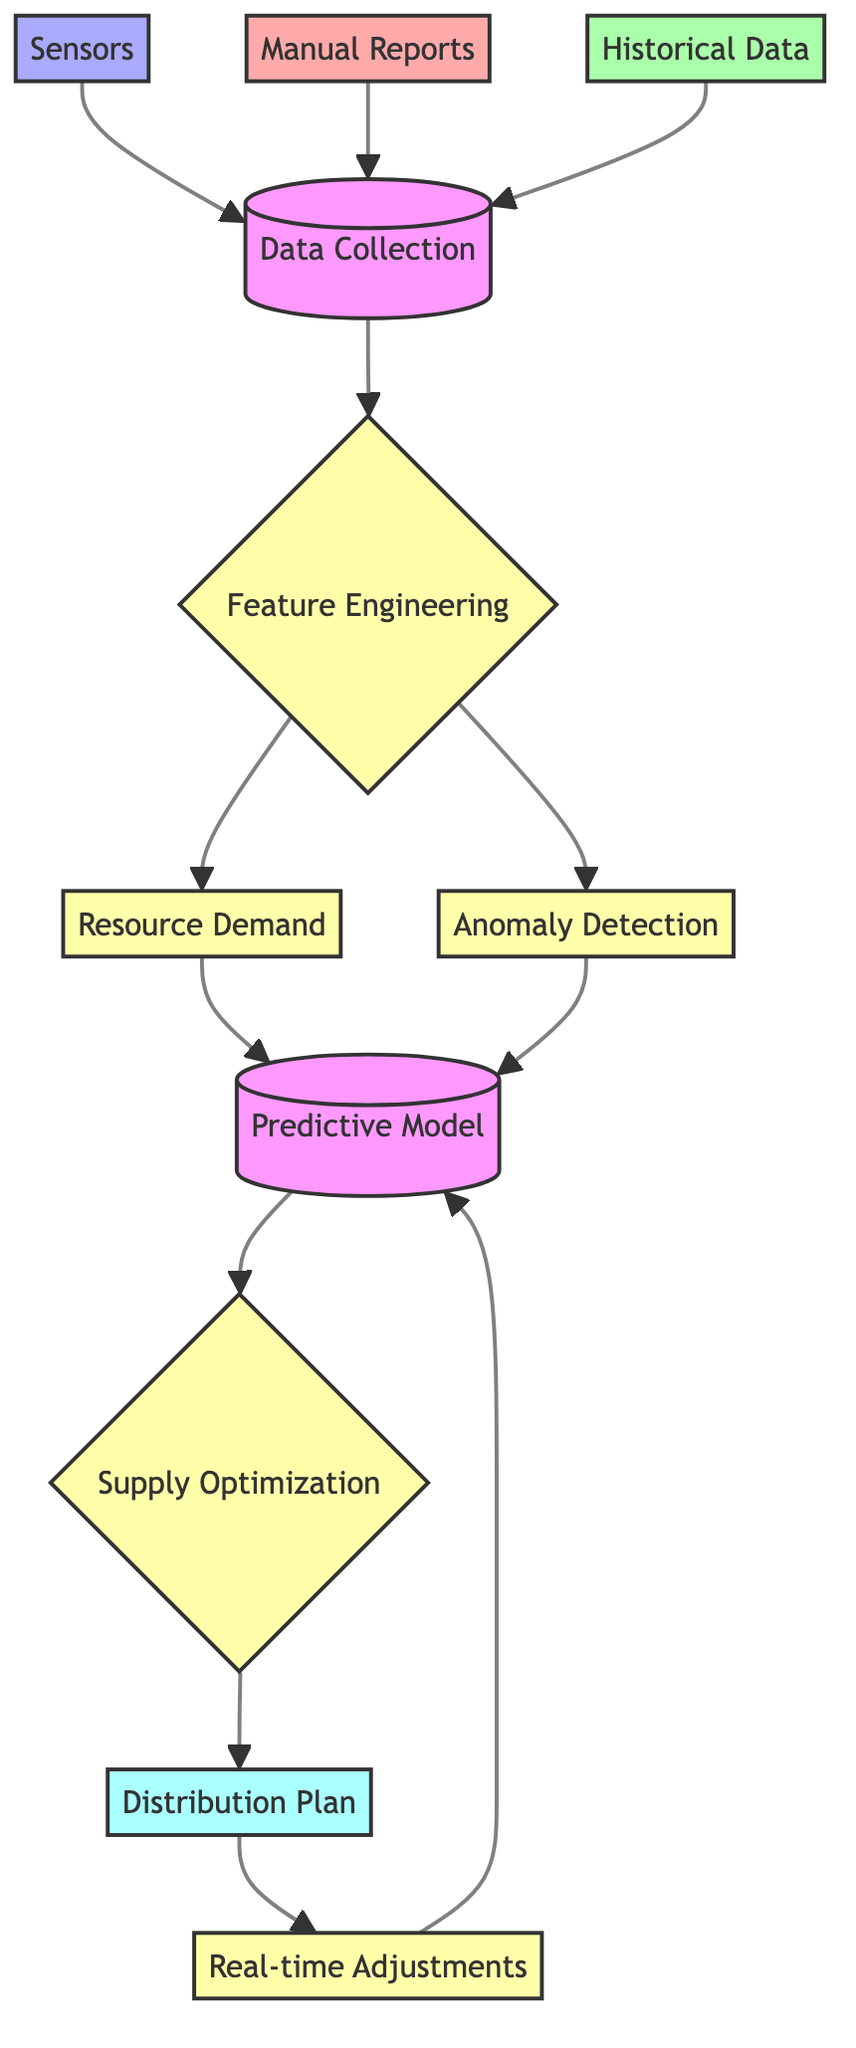What is the first node in the diagram? The first node listed in the diagram is "Data Collection", which is the starting point of the flowchart. It is where all data inputs converge before further analysis.
Answer: Data Collection How many types of data sources are used for data collection? The diagram shows three data sources: Sensors, Manual Reports, and Historical Data. These nodes feed into the Data Collection process.
Answer: 3 What is the output of the predictive model node? The output of the Predictive Model node leads to the Supply Optimization process, indicating that the model's result is directed toward resource management.
Answer: Supply Optimization Which process follows "Feature Engineering"? After "Feature Engineering," the processes that follow are "Resource Demand" and "Anomaly Detection". Both are parallel and rely on the outcome of the feature engineering stage.
Answer: Resource Demand and Anomaly Detection What do real-time adjustments connect back to in the diagram? Real-time Adjustments connect back to the Predictive Model node, indicating that the adjustments influence and feed back into the predictive analytics process for continuous refinement.
Answer: Predictive Model How many processes are shown in the flowchart? By reviewing the diagram, we count six distinct processes: Feature Engineering, Resource Demand, Anomaly Detection, Predictive Model, Supply Optimization, and Real-time Adjustments.
Answer: 6 What type of reports contribute to data collection aside from sensors? The diagram indicates that "Manual Reports" also contribute to the Data Collection process, highlighting the importance of human input alongside technological sensors.
Answer: Manual Reports Which node is directly linked to the "Distribution Plan"? The "Supply Optimization" node is directly linked to the "Distribution Plan," showing that the optimized supply allocation is the basis for creating the distribution strategy.
Answer: Supply Optimization What is the role of "Anomaly Detection" in this diagram? "Anomaly Detection" serves as a process that analyzes data for inconsistencies or irregularities, which is crucial for ensuring accurate resource management in the settlement.
Answer: Analyze irregularities 